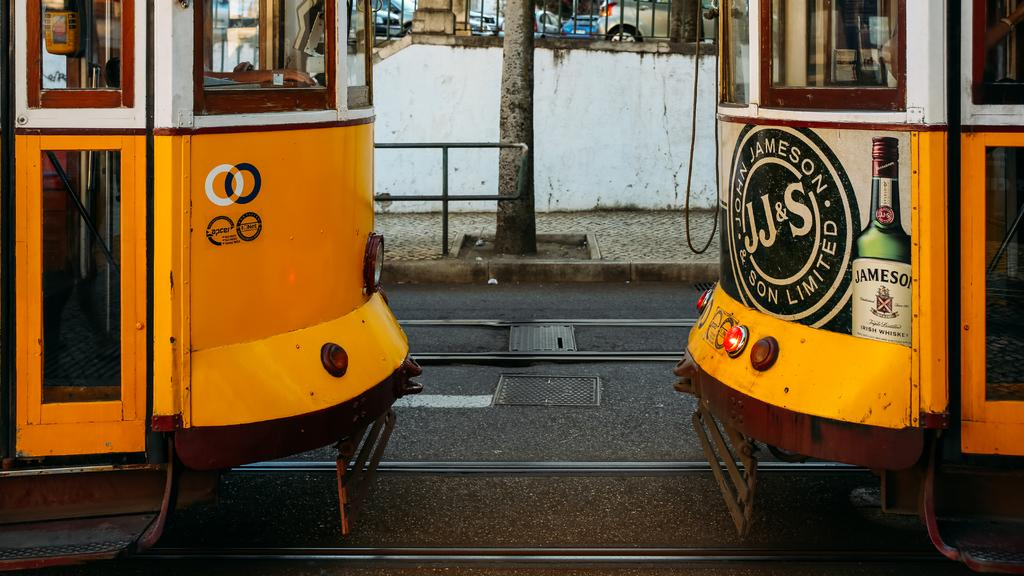What type of vehicles are on the track in the image? There are locomotives on the track in the image. What type of utility access point can be seen on the road? There is a manhole on the road in the image. What part of a tree is visible in the image? The bark of a tree is visible in the image. What type of barrier is present in the image? There is a metal fence in the image. What type of structure is visible in the image? There is a wall in the image. What type of vehicles are parked aside in the image? There are cars parked aside in the image. Can you see a pig in the image? No, there is no pig present in the image. 